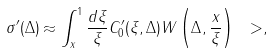<formula> <loc_0><loc_0><loc_500><loc_500>\sigma ^ { \prime } ( \Delta ) \approx \int _ { x } ^ { 1 } \frac { d \xi } { \xi } C ^ { \prime } _ { 0 } ( \xi , \Delta ) W \left ( \Delta , \frac { x } { \xi } \right ) \ > ,</formula> 